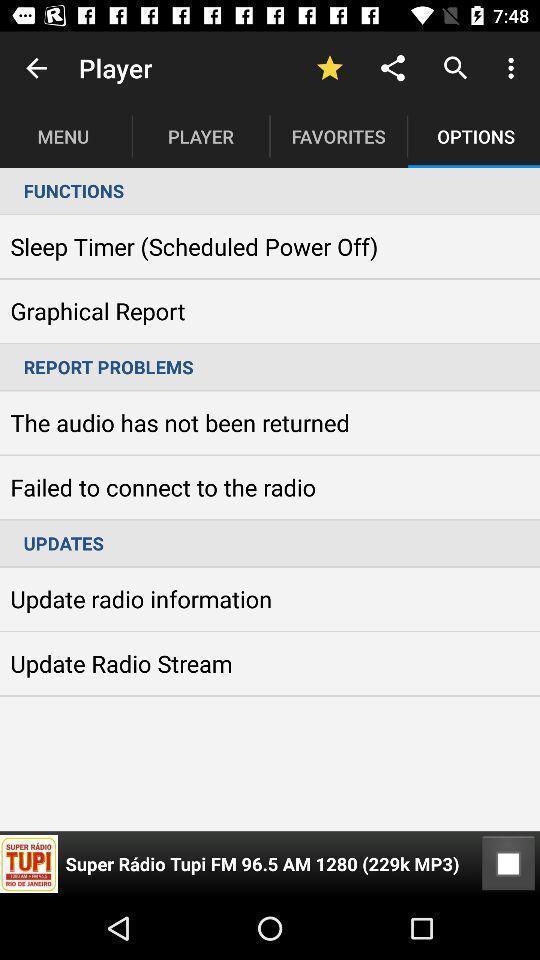Explain what's happening in this screen capture. Screen shows options in music player app. 